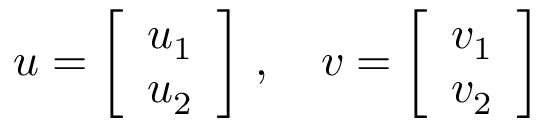<formula> <loc_0><loc_0><loc_500><loc_500>u = { \left [ \begin{array} { l } { u _ { 1 } } \\ { u _ { 2 } } \end{array} \right ] } , \quad v = { \left [ \begin{array} { l } { v _ { 1 } } \\ { v _ { 2 } } \end{array} \right ] }</formula> 